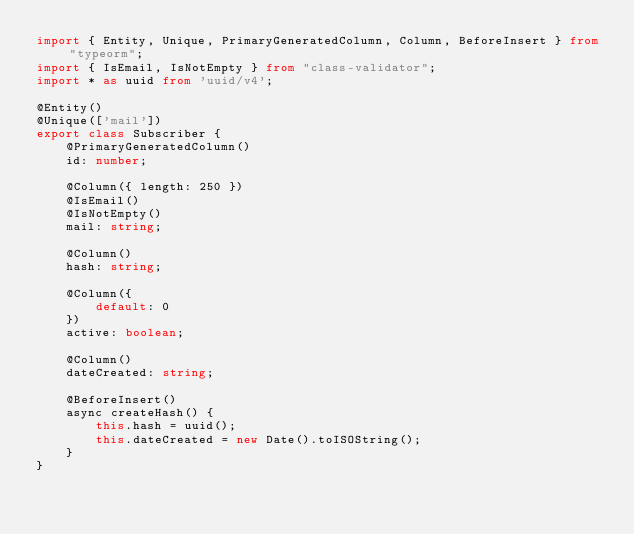<code> <loc_0><loc_0><loc_500><loc_500><_TypeScript_>import { Entity, Unique, PrimaryGeneratedColumn, Column, BeforeInsert } from "typeorm";
import { IsEmail, IsNotEmpty } from "class-validator";
import * as uuid from 'uuid/v4';

@Entity()
@Unique(['mail'])
export class Subscriber {
    @PrimaryGeneratedColumn()
    id: number;

    @Column({ length: 250 })
    @IsEmail()
    @IsNotEmpty()
    mail: string;

    @Column()
    hash: string;

    @Column({
        default: 0
    })
    active: boolean;

    @Column()
    dateCreated: string;

    @BeforeInsert()
    async createHash() {
        this.hash = uuid();
        this.dateCreated = new Date().toISOString();
    }
}
</code> 